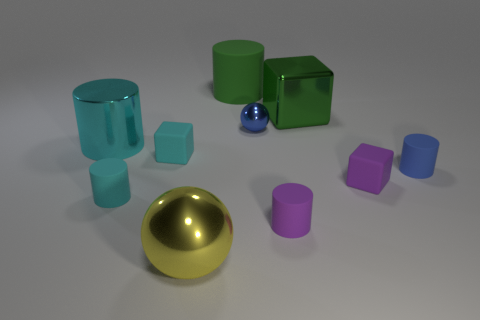Subtract all purple cylinders. How many cylinders are left? 4 Subtract all big rubber cylinders. How many cylinders are left? 4 Subtract all blue cylinders. Subtract all yellow cubes. How many cylinders are left? 4 Subtract all cubes. How many objects are left? 7 Add 8 purple things. How many purple things are left? 10 Add 2 tiny blue spheres. How many tiny blue spheres exist? 3 Subtract 1 blue cylinders. How many objects are left? 9 Subtract all spheres. Subtract all small blue spheres. How many objects are left? 7 